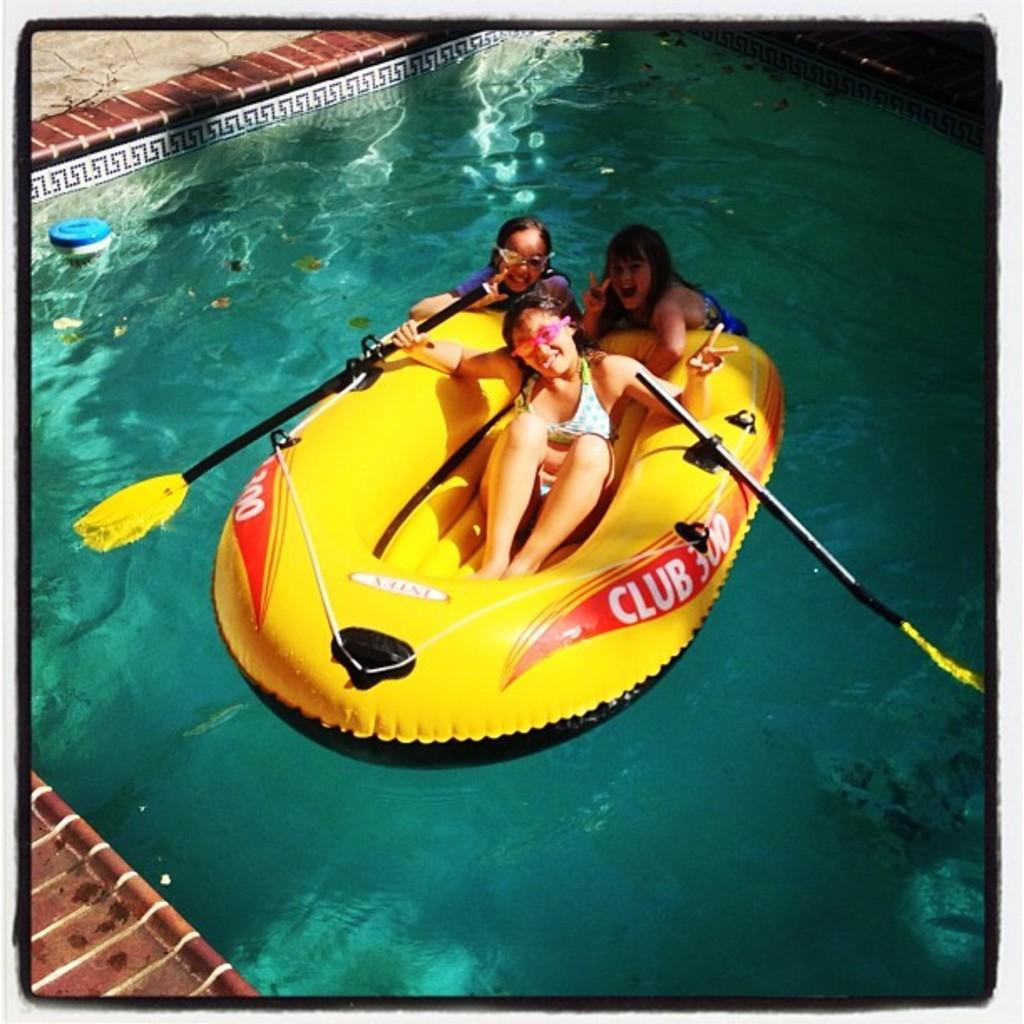Please provide a concise description of this image. In this picture there are three small girls, sitting in the yellow color boat. Behind there is a swimming pool water and brown color flooring tiles. 